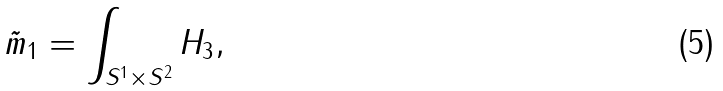<formula> <loc_0><loc_0><loc_500><loc_500>\tilde { m } _ { 1 } = \int _ { S ^ { 1 } \times S ^ { 2 } } H _ { 3 } ,</formula> 